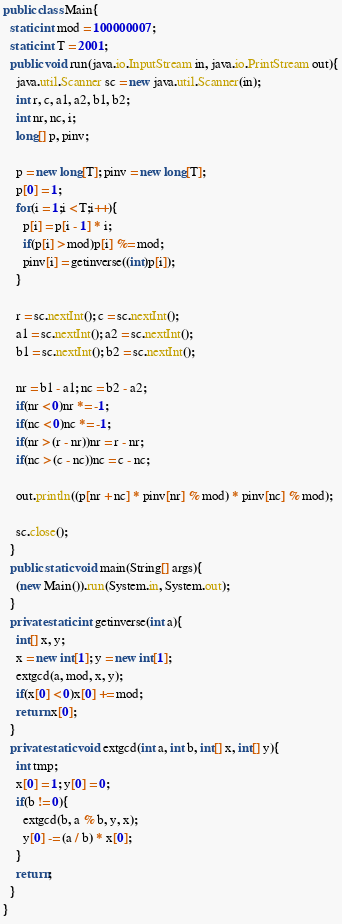Convert code to text. <code><loc_0><loc_0><loc_500><loc_500><_Java_>public class Main{
  static int mod = 100000007;
  static int T = 2001;
  public void run(java.io.InputStream in, java.io.PrintStream out){
    java.util.Scanner sc = new java.util.Scanner(in);
    int r, c, a1, a2, b1, b2;
    int nr, nc, i;
    long[] p, pinv;

    p = new long[T]; pinv = new long[T];
    p[0] = 1;
    for(i = 1;i < T;i++){
      p[i] = p[i - 1] * i;
      if(p[i] > mod)p[i] %= mod;
      pinv[i] = getinverse((int)p[i]);
    }

    r = sc.nextInt(); c = sc.nextInt();
    a1 = sc.nextInt(); a2 = sc.nextInt();
    b1 = sc.nextInt(); b2 = sc.nextInt();

    nr = b1 - a1; nc = b2 - a2;
    if(nr < 0)nr *= -1;
    if(nc < 0)nc *= -1;
    if(nr > (r - nr))nr = r - nr;
    if(nc > (c - nc))nc = c - nc;

    out.println((p[nr + nc] * pinv[nr] % mod) * pinv[nc] % mod);

    sc.close();
  }
  public static void main(String[] args){
    (new Main()).run(System.in, System.out);
  }
  private static int getinverse(int a){
    int[] x, y;
    x = new int[1]; y = new int[1];
    extgcd(a, mod, x, y);
    if(x[0] < 0)x[0] += mod;
    return x[0];
  }
  private static void extgcd(int a, int b, int[] x, int[] y){
    int tmp;
    x[0] = 1; y[0] = 0;
    if(b != 0){
      extgcd(b, a % b, y, x);
      y[0] -= (a / b) * x[0];
    }
    return;
  }
}</code> 